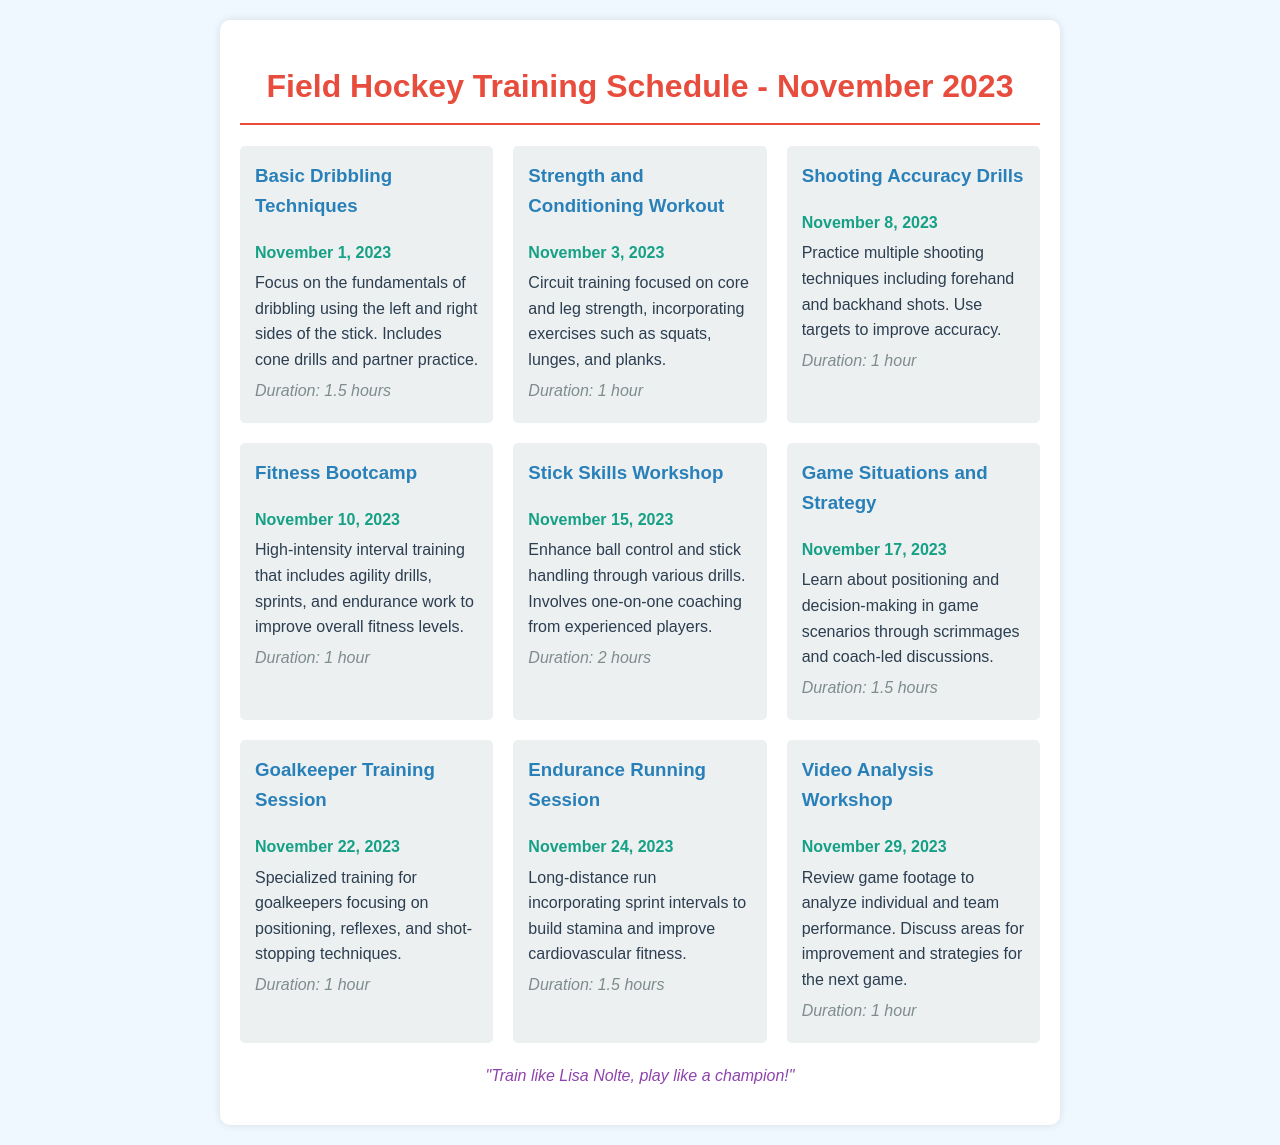What is the date for the Basic Dribbling Techniques session? The document states that the Basic Dribbling Techniques session is scheduled for November 1, 2023.
Answer: November 1, 2023 How long is the Stick Skills Workshop? The duration of the Stick Skills Workshop is mentioned in the document as 2 hours.
Answer: 2 hours What type of session is scheduled on November 10, 2023? On November 10, 2023, the document lists a Fitness Bootcamp session.
Answer: Fitness Bootcamp Which session focuses on shooting techniques? The document specifies that the Shooting Accuracy Drills session practices various shooting techniques.
Answer: Shooting Accuracy Drills How many sessions are scheduled in total for November 2023? By counting the individual sessions listed in the document, there are a total of 9 sessions.
Answer: 9 sessions What is the focus of the Goalkeeper Training Session? The document describes that the Goalkeeper Training Session focuses on positioning, reflexes, and shot-stopping techniques.
Answer: Goalkeeper Training Session Which session includes high-intensity interval training? The document states that the Fitness Bootcamp includes high-intensity interval training.
Answer: Fitness Bootcamp On which date can you attend the Video Analysis Workshop? The document mentions that the Video Analysis Workshop is scheduled for November 29, 2023.
Answer: November 29, 2023 